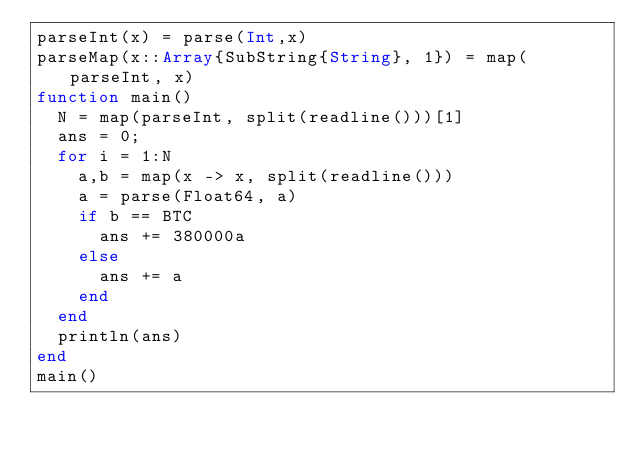Convert code to text. <code><loc_0><loc_0><loc_500><loc_500><_Julia_>parseInt(x) = parse(Int,x)
parseMap(x::Array{SubString{String}, 1}) = map(parseInt, x)
function main()
  N = map(parseInt, split(readline()))[1]
  ans = 0;
  for i = 1:N
  	a,b = map(x -> x, split(readline()))
    a = parse(Float64, a)
    if b == BTC
      ans += 380000a
    else
      ans += a
    end
  end
  println(ans)
end
main()</code> 